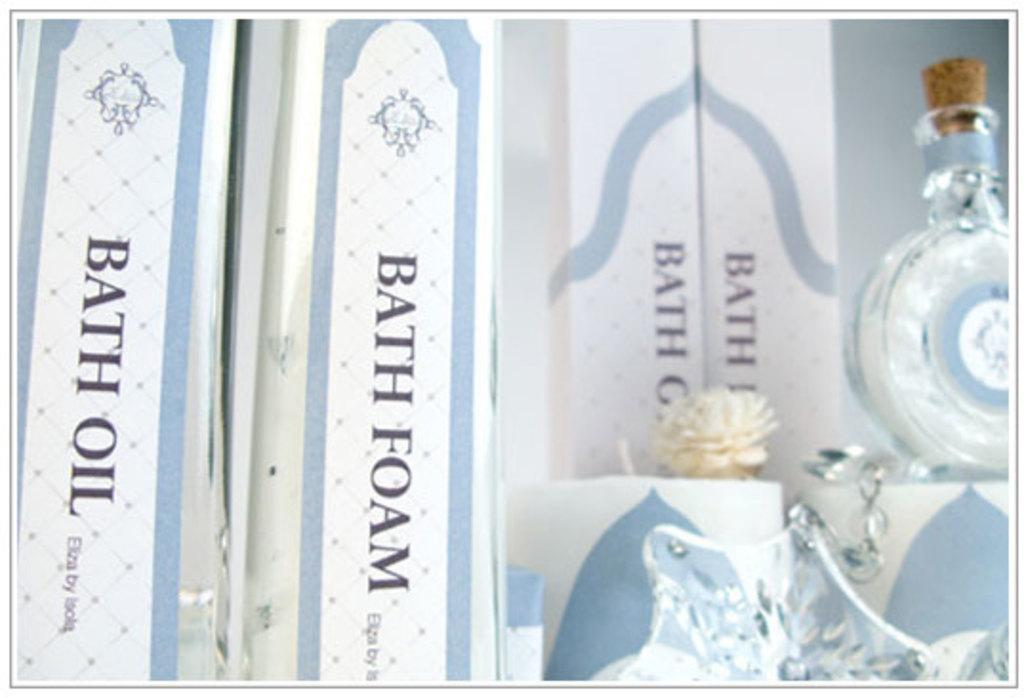What can be seen on the right side of the image? There is a bottle on the right side of the image. What is located at the bottom of the image? There is a crystal object at the bottom of the image. What type of objects are labeled with names in the image? There are boxes with names in the image. Is there an umbrella being used to protect the crystal object from the rain in the image? There is no umbrella present in the image, and the image does not depict any rain or need for protection from it. 